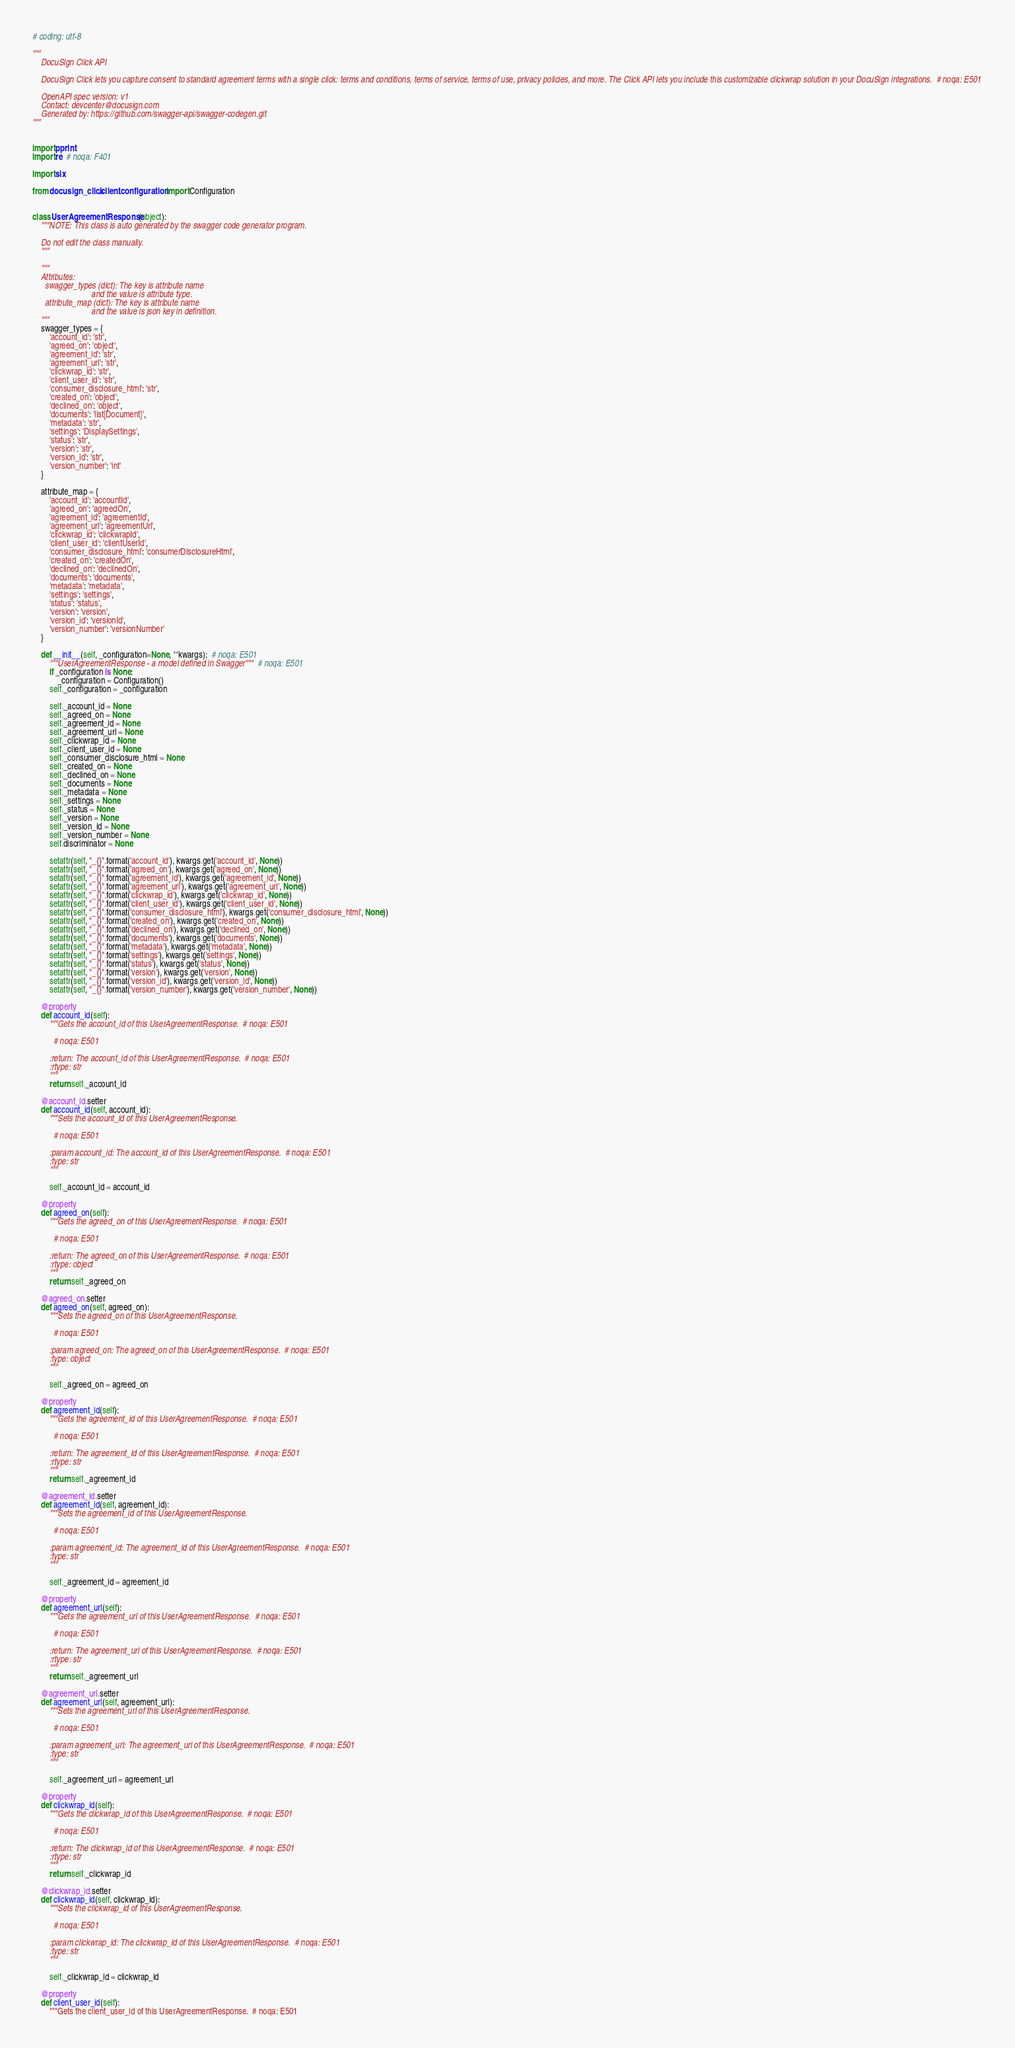<code> <loc_0><loc_0><loc_500><loc_500><_Python_># coding: utf-8

"""
    DocuSign Click API

    DocuSign Click lets you capture consent to standard agreement terms with a single click: terms and conditions, terms of service, terms of use, privacy policies, and more. The Click API lets you include this customizable clickwrap solution in your DocuSign integrations.  # noqa: E501

    OpenAPI spec version: v1
    Contact: devcenter@docusign.com
    Generated by: https://github.com/swagger-api/swagger-codegen.git
"""


import pprint
import re  # noqa: F401

import six

from docusign_click.client.configuration import Configuration


class UserAgreementResponse(object):
    """NOTE: This class is auto generated by the swagger code generator program.

    Do not edit the class manually.
    """

    """
    Attributes:
      swagger_types (dict): The key is attribute name
                            and the value is attribute type.
      attribute_map (dict): The key is attribute name
                            and the value is json key in definition.
    """
    swagger_types = {
        'account_id': 'str',
        'agreed_on': 'object',
        'agreement_id': 'str',
        'agreement_url': 'str',
        'clickwrap_id': 'str',
        'client_user_id': 'str',
        'consumer_disclosure_html': 'str',
        'created_on': 'object',
        'declined_on': 'object',
        'documents': 'list[Document]',
        'metadata': 'str',
        'settings': 'DisplaySettings',
        'status': 'str',
        'version': 'str',
        'version_id': 'str',
        'version_number': 'int'
    }

    attribute_map = {
        'account_id': 'accountId',
        'agreed_on': 'agreedOn',
        'agreement_id': 'agreementId',
        'agreement_url': 'agreementUrl',
        'clickwrap_id': 'clickwrapId',
        'client_user_id': 'clientUserId',
        'consumer_disclosure_html': 'consumerDisclosureHtml',
        'created_on': 'createdOn',
        'declined_on': 'declinedOn',
        'documents': 'documents',
        'metadata': 'metadata',
        'settings': 'settings',
        'status': 'status',
        'version': 'version',
        'version_id': 'versionId',
        'version_number': 'versionNumber'
    }

    def __init__(self, _configuration=None, **kwargs):  # noqa: E501
        """UserAgreementResponse - a model defined in Swagger"""  # noqa: E501
        if _configuration is None:
            _configuration = Configuration()
        self._configuration = _configuration

        self._account_id = None
        self._agreed_on = None
        self._agreement_id = None
        self._agreement_url = None
        self._clickwrap_id = None
        self._client_user_id = None
        self._consumer_disclosure_html = None
        self._created_on = None
        self._declined_on = None
        self._documents = None
        self._metadata = None
        self._settings = None
        self._status = None
        self._version = None
        self._version_id = None
        self._version_number = None
        self.discriminator = None

        setattr(self, "_{}".format('account_id'), kwargs.get('account_id', None))
        setattr(self, "_{}".format('agreed_on'), kwargs.get('agreed_on', None))
        setattr(self, "_{}".format('agreement_id'), kwargs.get('agreement_id', None))
        setattr(self, "_{}".format('agreement_url'), kwargs.get('agreement_url', None))
        setattr(self, "_{}".format('clickwrap_id'), kwargs.get('clickwrap_id', None))
        setattr(self, "_{}".format('client_user_id'), kwargs.get('client_user_id', None))
        setattr(self, "_{}".format('consumer_disclosure_html'), kwargs.get('consumer_disclosure_html', None))
        setattr(self, "_{}".format('created_on'), kwargs.get('created_on', None))
        setattr(self, "_{}".format('declined_on'), kwargs.get('declined_on', None))
        setattr(self, "_{}".format('documents'), kwargs.get('documents', None))
        setattr(self, "_{}".format('metadata'), kwargs.get('metadata', None))
        setattr(self, "_{}".format('settings'), kwargs.get('settings', None))
        setattr(self, "_{}".format('status'), kwargs.get('status', None))
        setattr(self, "_{}".format('version'), kwargs.get('version', None))
        setattr(self, "_{}".format('version_id'), kwargs.get('version_id', None))
        setattr(self, "_{}".format('version_number'), kwargs.get('version_number', None))

    @property
    def account_id(self):
        """Gets the account_id of this UserAgreementResponse.  # noqa: E501

          # noqa: E501

        :return: The account_id of this UserAgreementResponse.  # noqa: E501
        :rtype: str
        """
        return self._account_id

    @account_id.setter
    def account_id(self, account_id):
        """Sets the account_id of this UserAgreementResponse.

          # noqa: E501

        :param account_id: The account_id of this UserAgreementResponse.  # noqa: E501
        :type: str
        """

        self._account_id = account_id

    @property
    def agreed_on(self):
        """Gets the agreed_on of this UserAgreementResponse.  # noqa: E501

          # noqa: E501

        :return: The agreed_on of this UserAgreementResponse.  # noqa: E501
        :rtype: object
        """
        return self._agreed_on

    @agreed_on.setter
    def agreed_on(self, agreed_on):
        """Sets the agreed_on of this UserAgreementResponse.

          # noqa: E501

        :param agreed_on: The agreed_on of this UserAgreementResponse.  # noqa: E501
        :type: object
        """

        self._agreed_on = agreed_on

    @property
    def agreement_id(self):
        """Gets the agreement_id of this UserAgreementResponse.  # noqa: E501

          # noqa: E501

        :return: The agreement_id of this UserAgreementResponse.  # noqa: E501
        :rtype: str
        """
        return self._agreement_id

    @agreement_id.setter
    def agreement_id(self, agreement_id):
        """Sets the agreement_id of this UserAgreementResponse.

          # noqa: E501

        :param agreement_id: The agreement_id of this UserAgreementResponse.  # noqa: E501
        :type: str
        """

        self._agreement_id = agreement_id

    @property
    def agreement_url(self):
        """Gets the agreement_url of this UserAgreementResponse.  # noqa: E501

          # noqa: E501

        :return: The agreement_url of this UserAgreementResponse.  # noqa: E501
        :rtype: str
        """
        return self._agreement_url

    @agreement_url.setter
    def agreement_url(self, agreement_url):
        """Sets the agreement_url of this UserAgreementResponse.

          # noqa: E501

        :param agreement_url: The agreement_url of this UserAgreementResponse.  # noqa: E501
        :type: str
        """

        self._agreement_url = agreement_url

    @property
    def clickwrap_id(self):
        """Gets the clickwrap_id of this UserAgreementResponse.  # noqa: E501

          # noqa: E501

        :return: The clickwrap_id of this UserAgreementResponse.  # noqa: E501
        :rtype: str
        """
        return self._clickwrap_id

    @clickwrap_id.setter
    def clickwrap_id(self, clickwrap_id):
        """Sets the clickwrap_id of this UserAgreementResponse.

          # noqa: E501

        :param clickwrap_id: The clickwrap_id of this UserAgreementResponse.  # noqa: E501
        :type: str
        """

        self._clickwrap_id = clickwrap_id

    @property
    def client_user_id(self):
        """Gets the client_user_id of this UserAgreementResponse.  # noqa: E501
</code> 